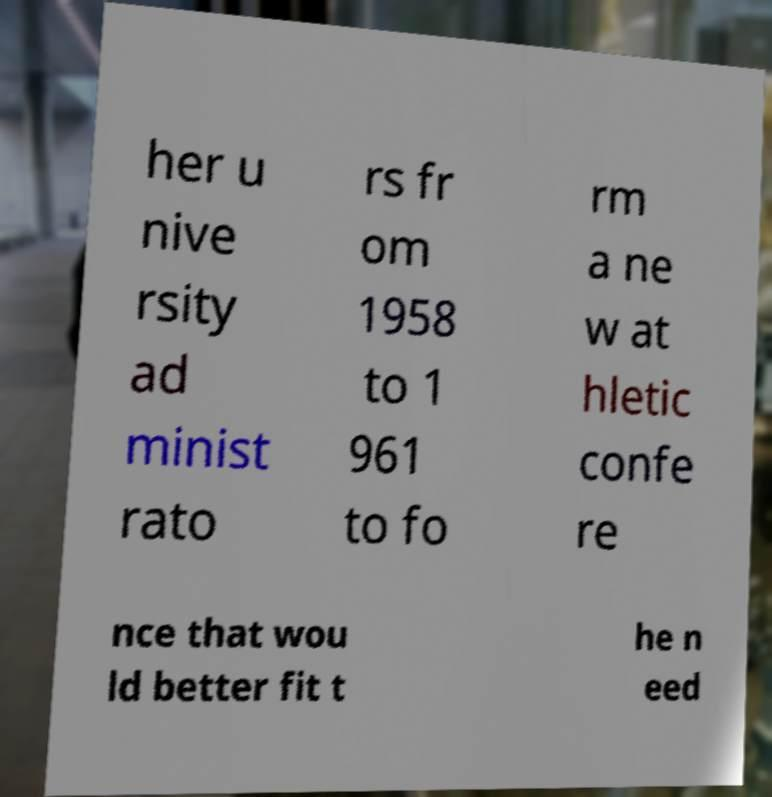Can you read and provide the text displayed in the image?This photo seems to have some interesting text. Can you extract and type it out for me? her u nive rsity ad minist rato rs fr om 1958 to 1 961 to fo rm a ne w at hletic confe re nce that wou ld better fit t he n eed 